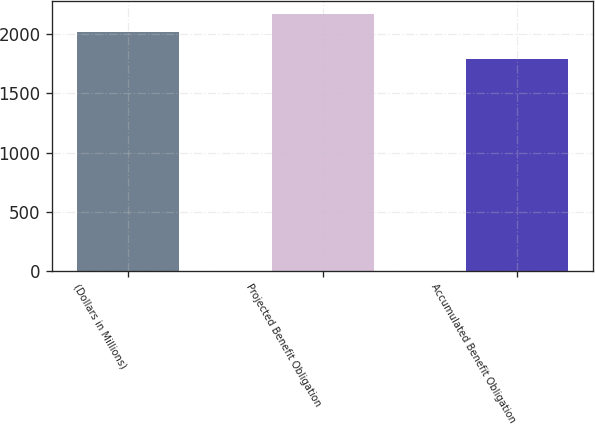<chart> <loc_0><loc_0><loc_500><loc_500><bar_chart><fcel>(Dollars in Millions)<fcel>Projected Benefit Obligation<fcel>Accumulated Benefit Obligation<nl><fcel>2018<fcel>2176<fcel>1793<nl></chart> 